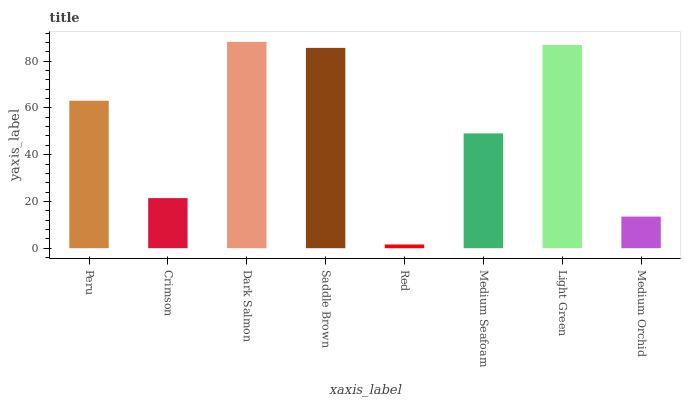Is Red the minimum?
Answer yes or no. Yes. Is Dark Salmon the maximum?
Answer yes or no. Yes. Is Crimson the minimum?
Answer yes or no. No. Is Crimson the maximum?
Answer yes or no. No. Is Peru greater than Crimson?
Answer yes or no. Yes. Is Crimson less than Peru?
Answer yes or no. Yes. Is Crimson greater than Peru?
Answer yes or no. No. Is Peru less than Crimson?
Answer yes or no. No. Is Peru the high median?
Answer yes or no. Yes. Is Medium Seafoam the low median?
Answer yes or no. Yes. Is Medium Orchid the high median?
Answer yes or no. No. Is Peru the low median?
Answer yes or no. No. 